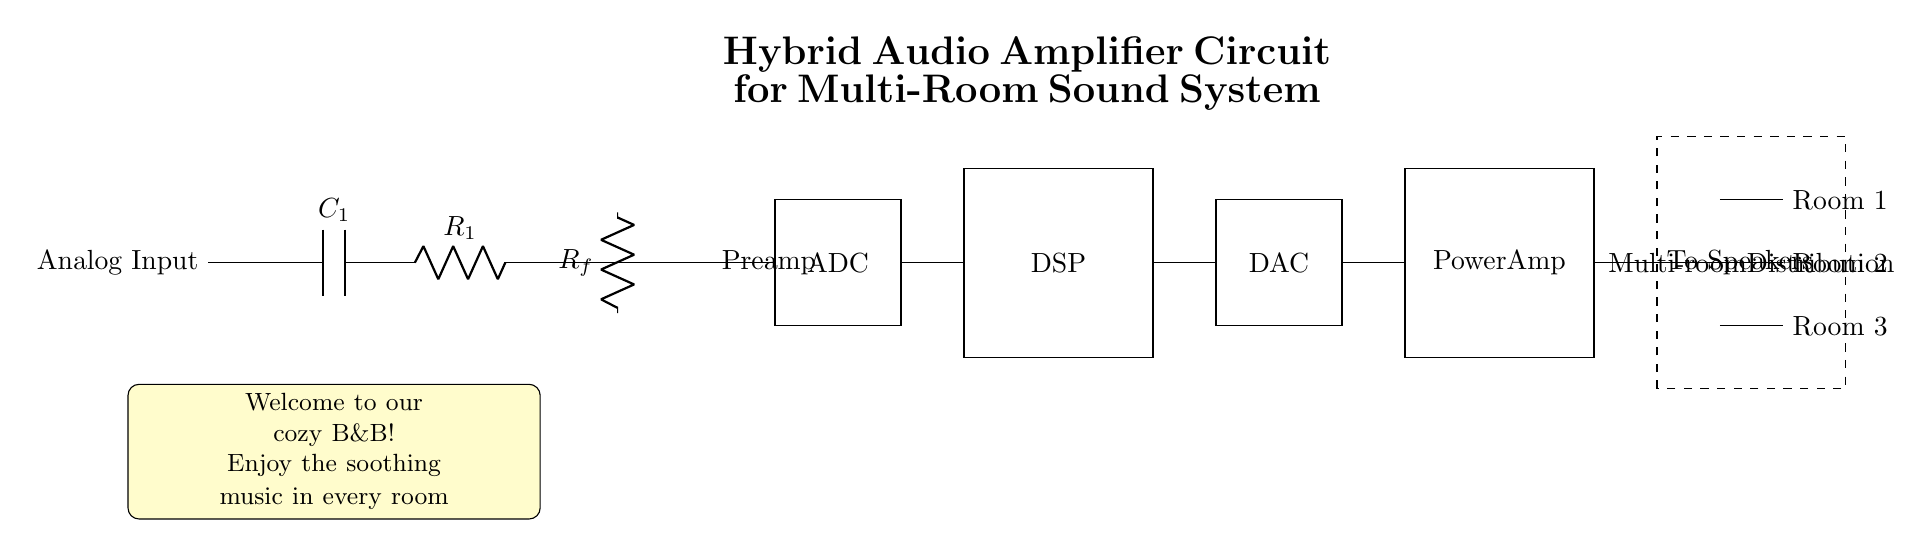What is the first component in the circuit? The first component in the circuit is a capacitor labeled C1, which is connected to the analog input, serving to block DC voltage and allow AC signals to pass through.
Answer: C1 What is the purpose of the ADC in this circuit? The ADC (Analog to Digital Converter) converts the analog signal received from the preamplifier into a digital signal, making it suitable for processing by the DSP.
Answer: Digital signal processing How many rooms can the audio be distributed to? The circuit features distribution to three rooms, as can be observed from the outputs labeled "Room 1," "Room 2," and "Room 3" connected to the multi-room distribution block.
Answer: Three What type of amplifier is represented in the last portion of the circuit? The last portion of the circuit is a power amplifier, which amplifies the processed signal from the DAC to a level suitable for driving speakers.
Answer: Power Amp What is the function of the DSP in this audio amplifier circuit? The DSP (Digital Signal Processor) processes the digital audio signal from the ADC, allowing for adjustments like equalization, mixing, and effects before sending it to the DAC for conversion back into an analog signal.
Answer: Signal processing What component connects the output of the power amplifier to the speakers? The connection from the output of the power amplifier to the speakers is made through the terminals labeled "To Speakers," which facilitate the final audio output.
Answer: To Speakers What type of circuit is depicted in this diagram? The circuit is a hybrid audio amplifier circuit that combines both analog and digital components for a multi-room sound system.
Answer: Hybrid audio amplifier 